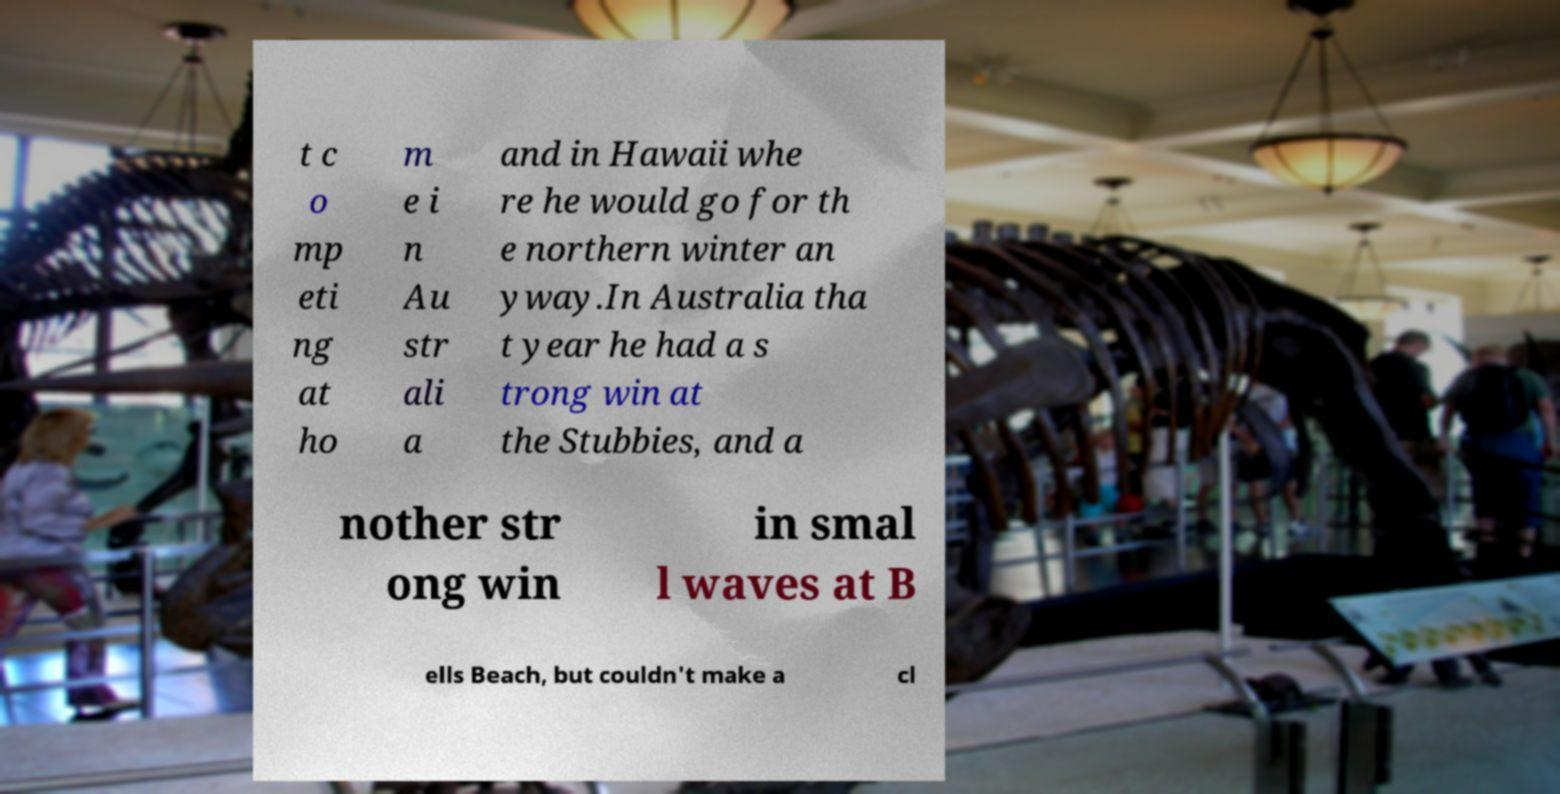Please identify and transcribe the text found in this image. t c o mp eti ng at ho m e i n Au str ali a and in Hawaii whe re he would go for th e northern winter an yway.In Australia tha t year he had a s trong win at the Stubbies, and a nother str ong win in smal l waves at B ells Beach, but couldn't make a cl 